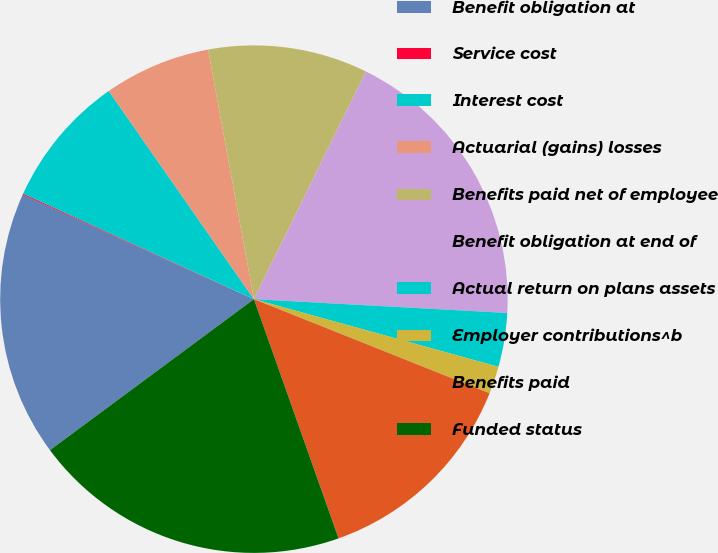Convert chart to OTSL. <chart><loc_0><loc_0><loc_500><loc_500><pie_chart><fcel>Benefit obligation at<fcel>Service cost<fcel>Interest cost<fcel>Actuarial (gains) losses<fcel>Benefits paid net of employee<fcel>Benefit obligation at end of<fcel>Actual return on plans assets<fcel>Employer contributions^b<fcel>Benefits paid<fcel>Funded status<nl><fcel>16.9%<fcel>0.07%<fcel>8.48%<fcel>6.8%<fcel>10.17%<fcel>18.59%<fcel>3.43%<fcel>1.75%<fcel>13.54%<fcel>20.27%<nl></chart> 